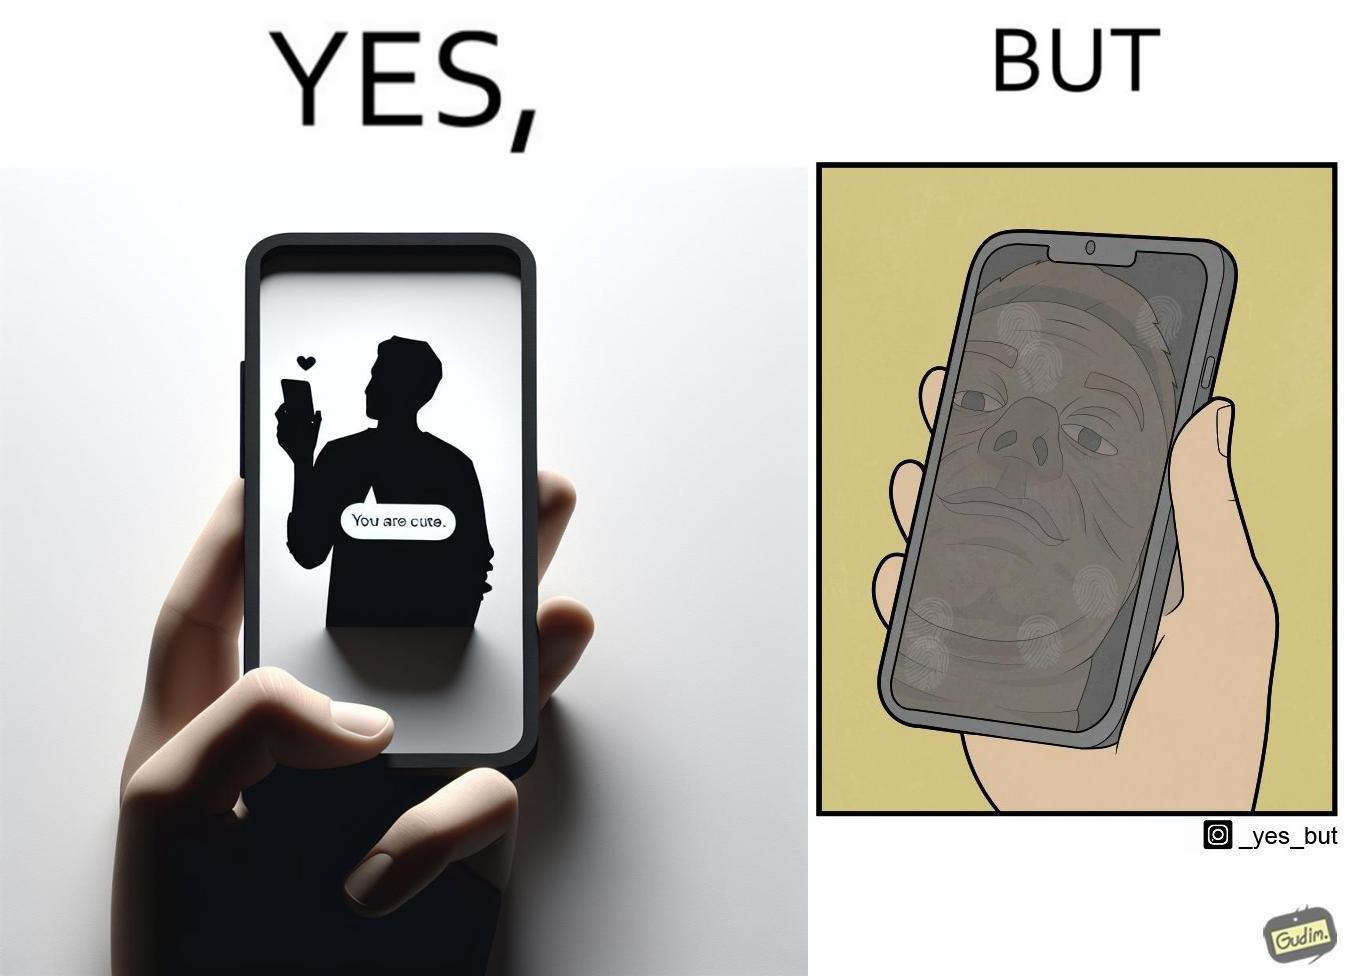Would you classify this image as satirical? Yes, this image is satirical. 